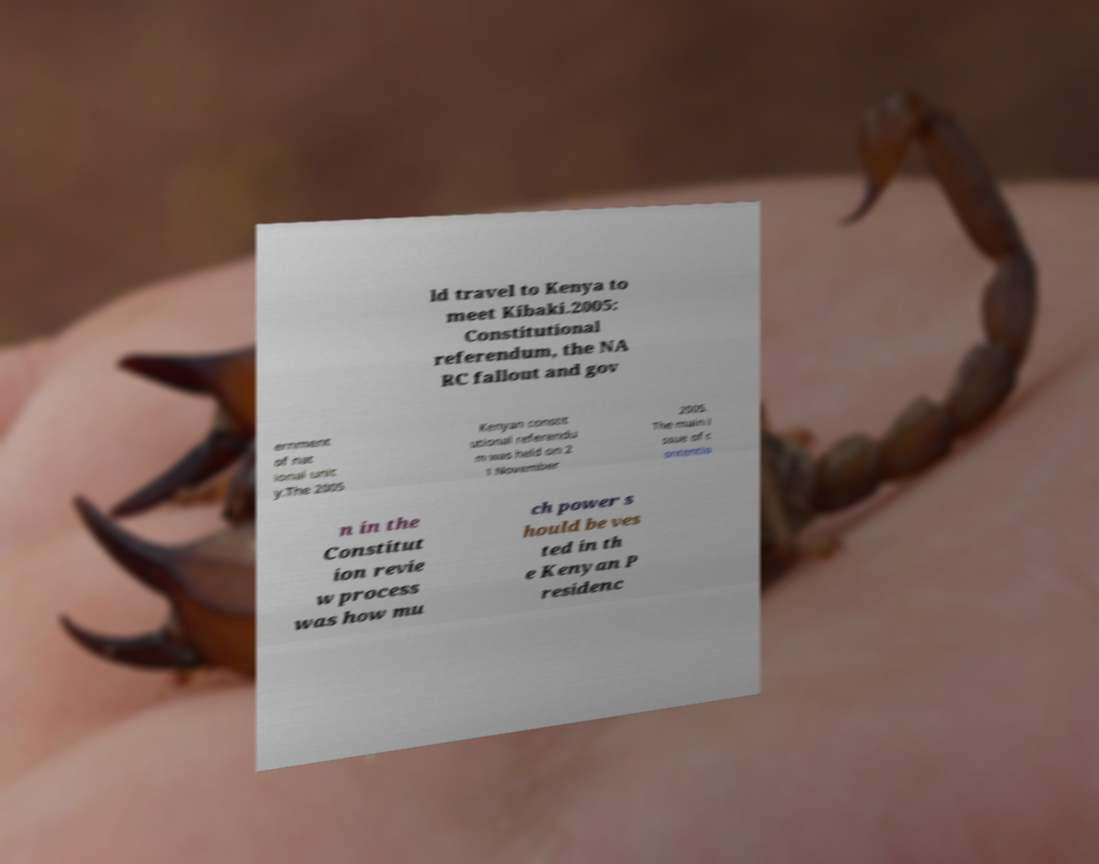Can you accurately transcribe the text from the provided image for me? ld travel to Kenya to meet Kibaki.2005: Constitutional referendum, the NA RC fallout and gov ernment of nat ional unit y.The 2005 Kenyan constit utional referendu m was held on 2 1 November 2005. The main i ssue of c ontentio n in the Constitut ion revie w process was how mu ch power s hould be ves ted in th e Kenyan P residenc 